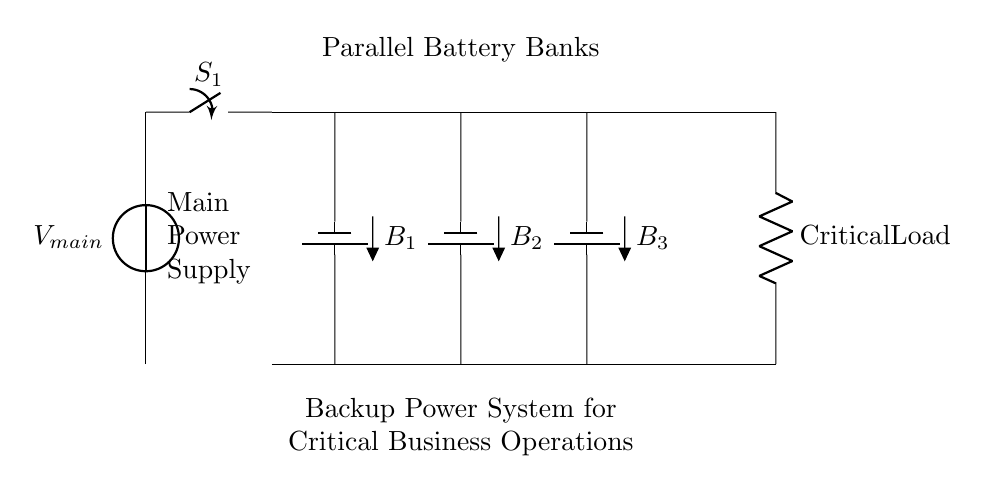What is the main power supply in this circuit? The main power supply is labeled as "V_main", which indicates the source voltage for the entire circuit.
Answer: V_main How many battery banks are in parallel? There are three battery banks denoted as "B_1", "B_2", and "B_3", shown connected in parallel towards the main load.
Answer: 3 What is the purpose of switch S_1? Switch S_1 is used to disconnect or connect the main power supply to the parallel battery banks, allowing maintenance or isolation of power supply.
Answer: Isolation What is the load connected to the battery banks? The load is labeled "Critical Load", which emphasizes that this circuit is designed to sustain essential business operations during power outages.
Answer: Critical Load What is the total voltage across the battery banks? Since the battery banks are in parallel, the total voltage remains the same as the individual voltages of the batteries provided they are identical; however, the specific voltage value is not indicated in the diagram.
Answer: Same as battery voltage What happens if one battery bank fails? If one battery bank fails, the other two can continue to operate and supply power to the critical load, because they are connected in parallel, which provides redundancy.
Answer: Redundancy Why is it important to have a backup power system for critical business operations? A backup power system ensures continuous operation and prevents downtime of essential services, crucial for business continuity especially during outages.
Answer: Continuous operation 